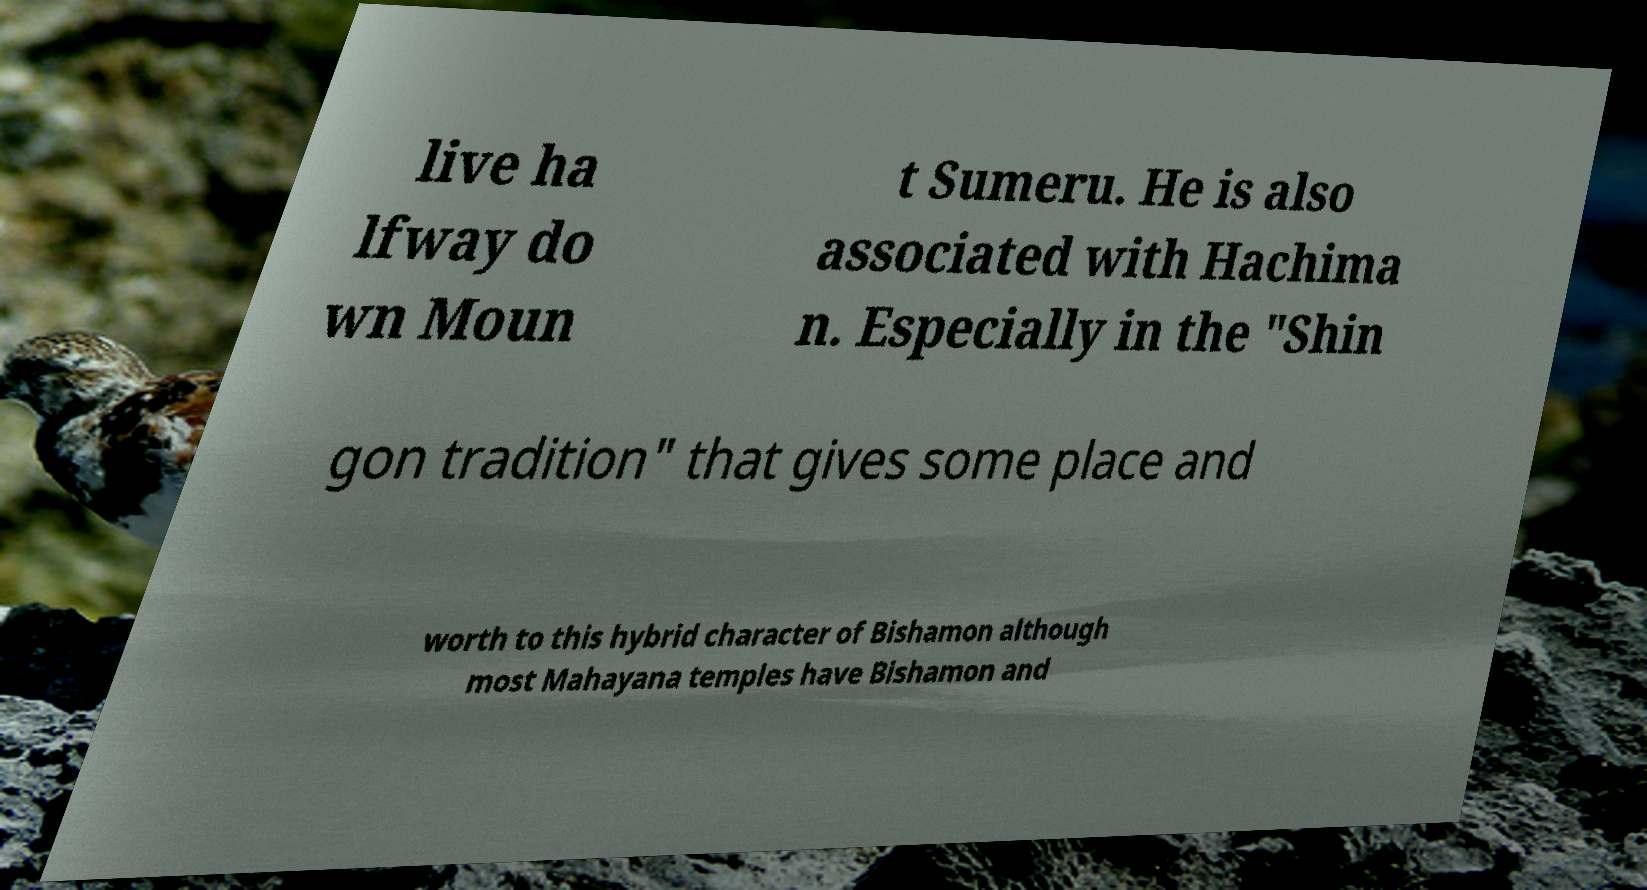Can you read and provide the text displayed in the image?This photo seems to have some interesting text. Can you extract and type it out for me? live ha lfway do wn Moun t Sumeru. He is also associated with Hachima n. Especially in the "Shin gon tradition" that gives some place and worth to this hybrid character of Bishamon although most Mahayana temples have Bishamon and 